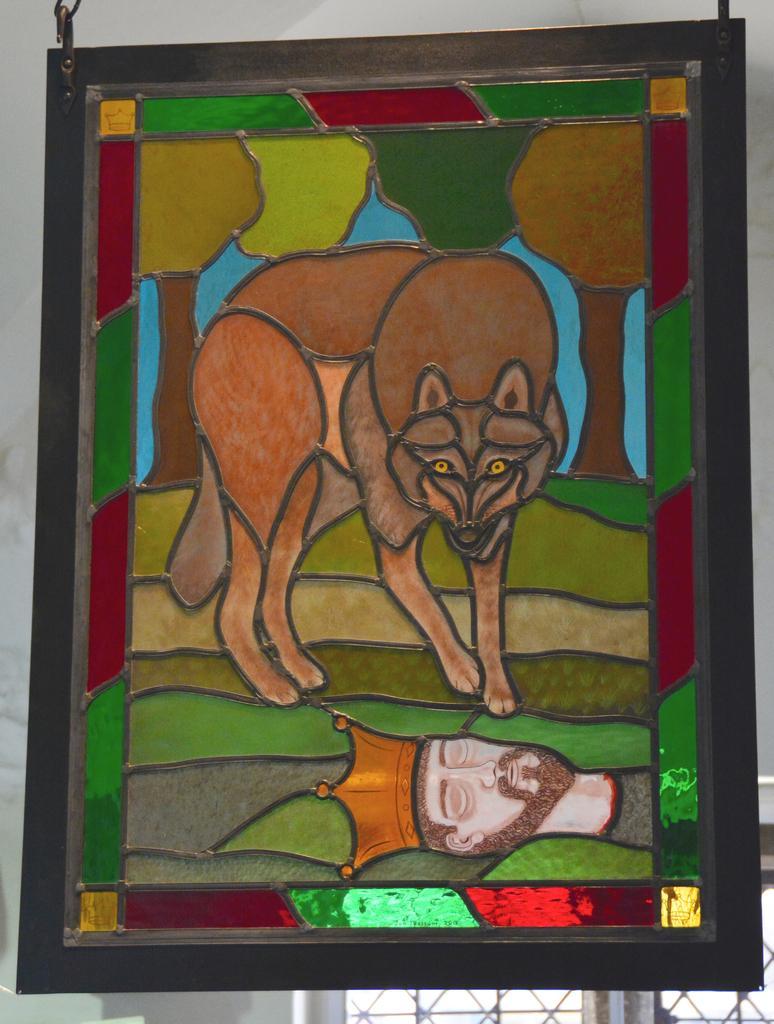How would you summarize this image in a sentence or two? In this picture we can see a photo frame in the front, there is a painting of a dog and a person's head in this frame, in the background there is a wall. 